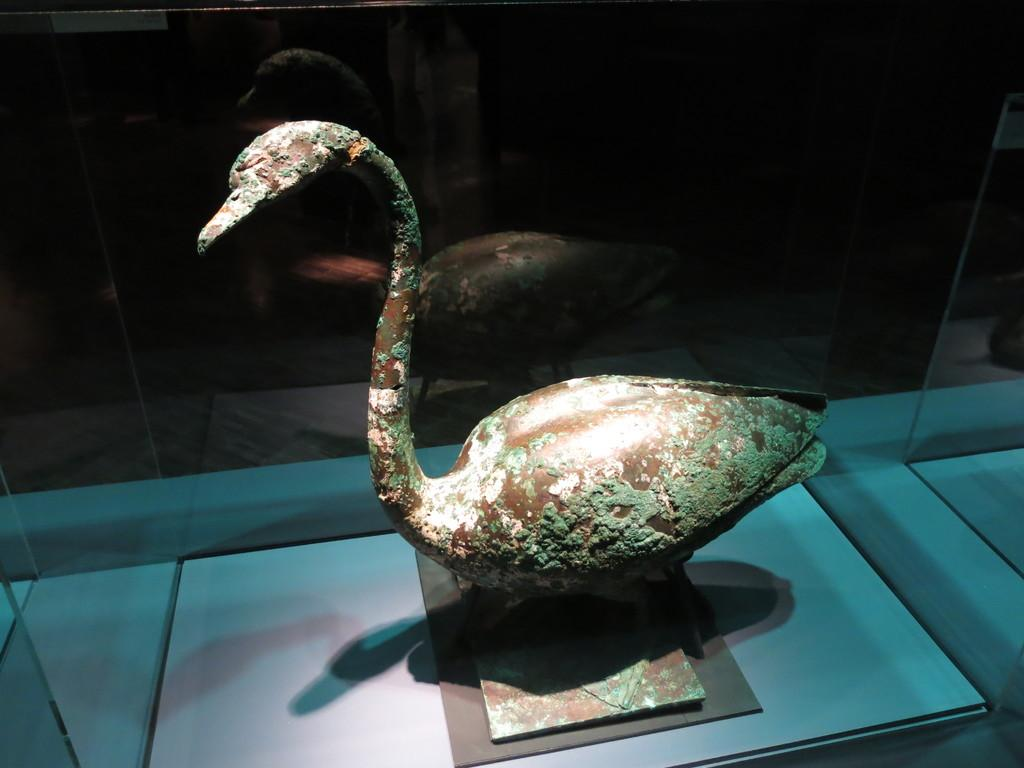What is the main subject of the image? The main subject of the image is an ancient duck sculpture. Where is the sculpture located? The sculpture is on a platform. What type of enclosure is the platform in? The platform is in a glass box. What type of beef dish is being prepared in the image? There is no beef dish or any indication of food preparation in the image; it features an ancient duck sculpture on a platform in a glass box. 